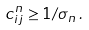Convert formula to latex. <formula><loc_0><loc_0><loc_500><loc_500>c ^ { n } _ { i j } \geq 1 / \sigma _ { n } \, .</formula> 